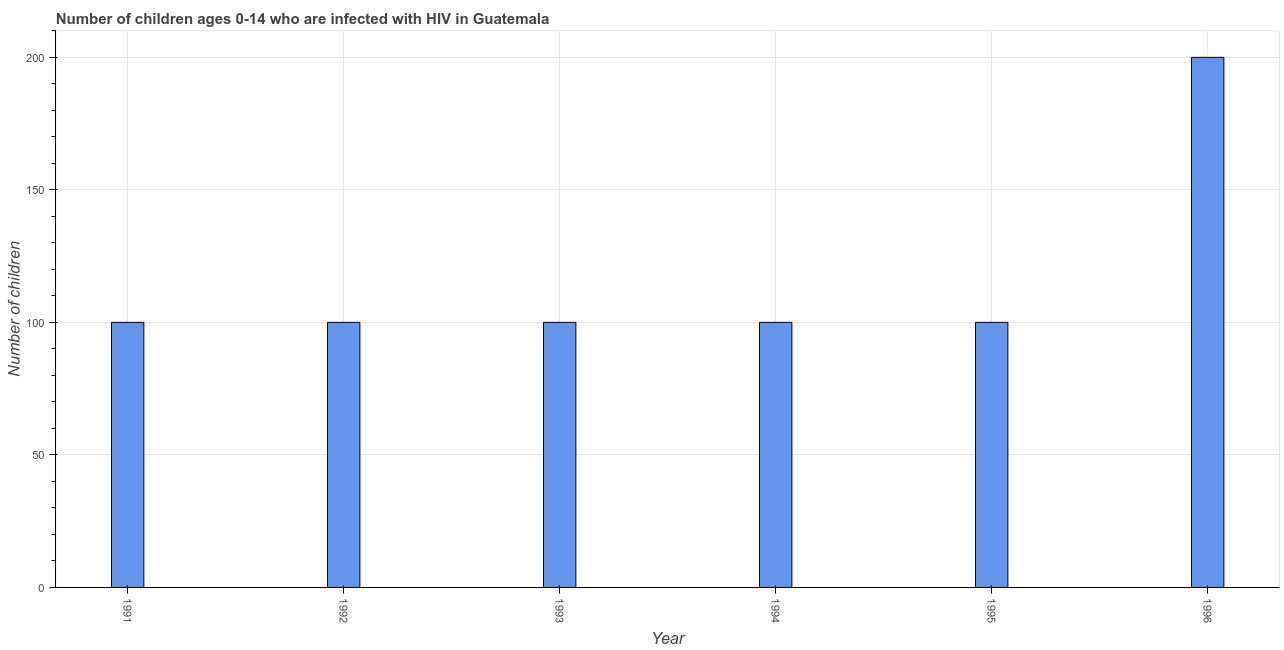Does the graph contain any zero values?
Keep it short and to the point. No. What is the title of the graph?
Ensure brevity in your answer.  Number of children ages 0-14 who are infected with HIV in Guatemala. What is the label or title of the Y-axis?
Your response must be concise. Number of children. What is the number of children living with hiv in 1993?
Give a very brief answer. 100. In which year was the number of children living with hiv minimum?
Your answer should be compact. 1991. What is the sum of the number of children living with hiv?
Provide a succinct answer. 700. What is the average number of children living with hiv per year?
Make the answer very short. 116. What is the median number of children living with hiv?
Ensure brevity in your answer.  100. In how many years, is the number of children living with hiv greater than 140 ?
Offer a terse response. 1. What is the ratio of the number of children living with hiv in 1994 to that in 1995?
Ensure brevity in your answer.  1. What is the difference between the highest and the second highest number of children living with hiv?
Make the answer very short. 100. Is the sum of the number of children living with hiv in 1992 and 1994 greater than the maximum number of children living with hiv across all years?
Give a very brief answer. No. Are all the bars in the graph horizontal?
Make the answer very short. No. How many years are there in the graph?
Give a very brief answer. 6. What is the difference between two consecutive major ticks on the Y-axis?
Your answer should be compact. 50. What is the Number of children of 1993?
Provide a short and direct response. 100. What is the Number of children in 1994?
Provide a short and direct response. 100. What is the difference between the Number of children in 1991 and 1996?
Make the answer very short. -100. What is the difference between the Number of children in 1992 and 1993?
Keep it short and to the point. 0. What is the difference between the Number of children in 1992 and 1995?
Your response must be concise. 0. What is the difference between the Number of children in 1992 and 1996?
Offer a terse response. -100. What is the difference between the Number of children in 1993 and 1994?
Your answer should be compact. 0. What is the difference between the Number of children in 1993 and 1995?
Ensure brevity in your answer.  0. What is the difference between the Number of children in 1993 and 1996?
Offer a terse response. -100. What is the difference between the Number of children in 1994 and 1996?
Your answer should be compact. -100. What is the difference between the Number of children in 1995 and 1996?
Your answer should be compact. -100. What is the ratio of the Number of children in 1991 to that in 1992?
Provide a succinct answer. 1. What is the ratio of the Number of children in 1991 to that in 1994?
Provide a short and direct response. 1. What is the ratio of the Number of children in 1991 to that in 1995?
Give a very brief answer. 1. What is the ratio of the Number of children in 1992 to that in 1993?
Provide a short and direct response. 1. What is the ratio of the Number of children in 1992 to that in 1995?
Provide a succinct answer. 1. What is the ratio of the Number of children in 1993 to that in 1994?
Make the answer very short. 1. What is the ratio of the Number of children in 1993 to that in 1996?
Your response must be concise. 0.5. What is the ratio of the Number of children in 1994 to that in 1995?
Ensure brevity in your answer.  1. What is the ratio of the Number of children in 1994 to that in 1996?
Offer a terse response. 0.5. 